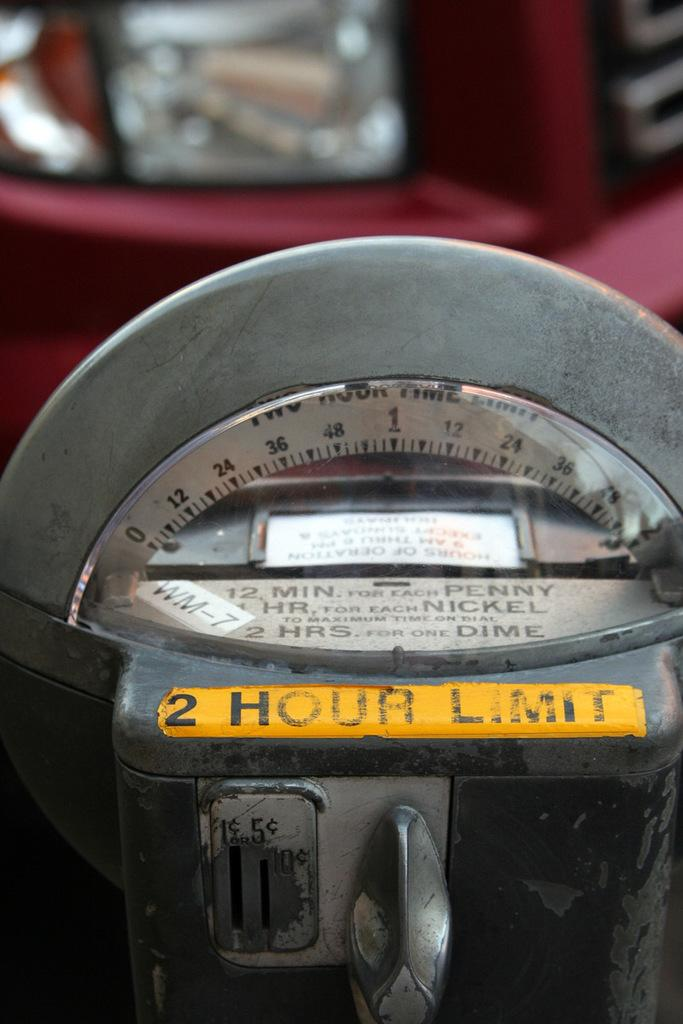<image>
Provide a brief description of the given image. A parking meter with a yellow sticker explaining the time limit. 